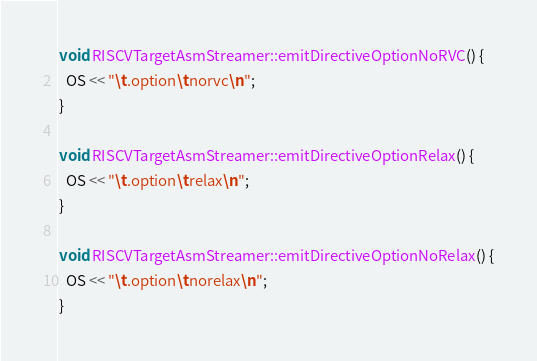<code> <loc_0><loc_0><loc_500><loc_500><_C++_>
void RISCVTargetAsmStreamer::emitDirectiveOptionNoRVC() {
  OS << "\t.option\tnorvc\n";
}

void RISCVTargetAsmStreamer::emitDirectiveOptionRelax() {
  OS << "\t.option\trelax\n";
}

void RISCVTargetAsmStreamer::emitDirectiveOptionNoRelax() {
  OS << "\t.option\tnorelax\n";
}
</code> 